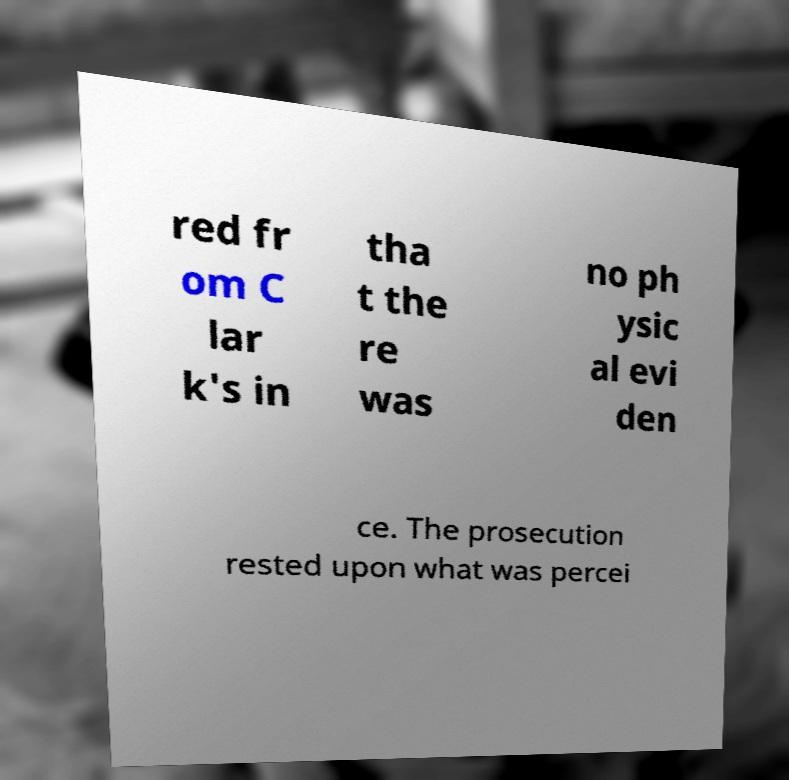Could you extract and type out the text from this image? red fr om C lar k's in tha t the re was no ph ysic al evi den ce. The prosecution rested upon what was percei 